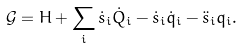Convert formula to latex. <formula><loc_0><loc_0><loc_500><loc_500>\mathcal { G } = H + \sum _ { i } \dot { s } _ { i } \dot { Q } _ { i } - \dot { s } _ { i } \dot { q } _ { i } - \ddot { s } _ { i } q _ { i } .</formula> 